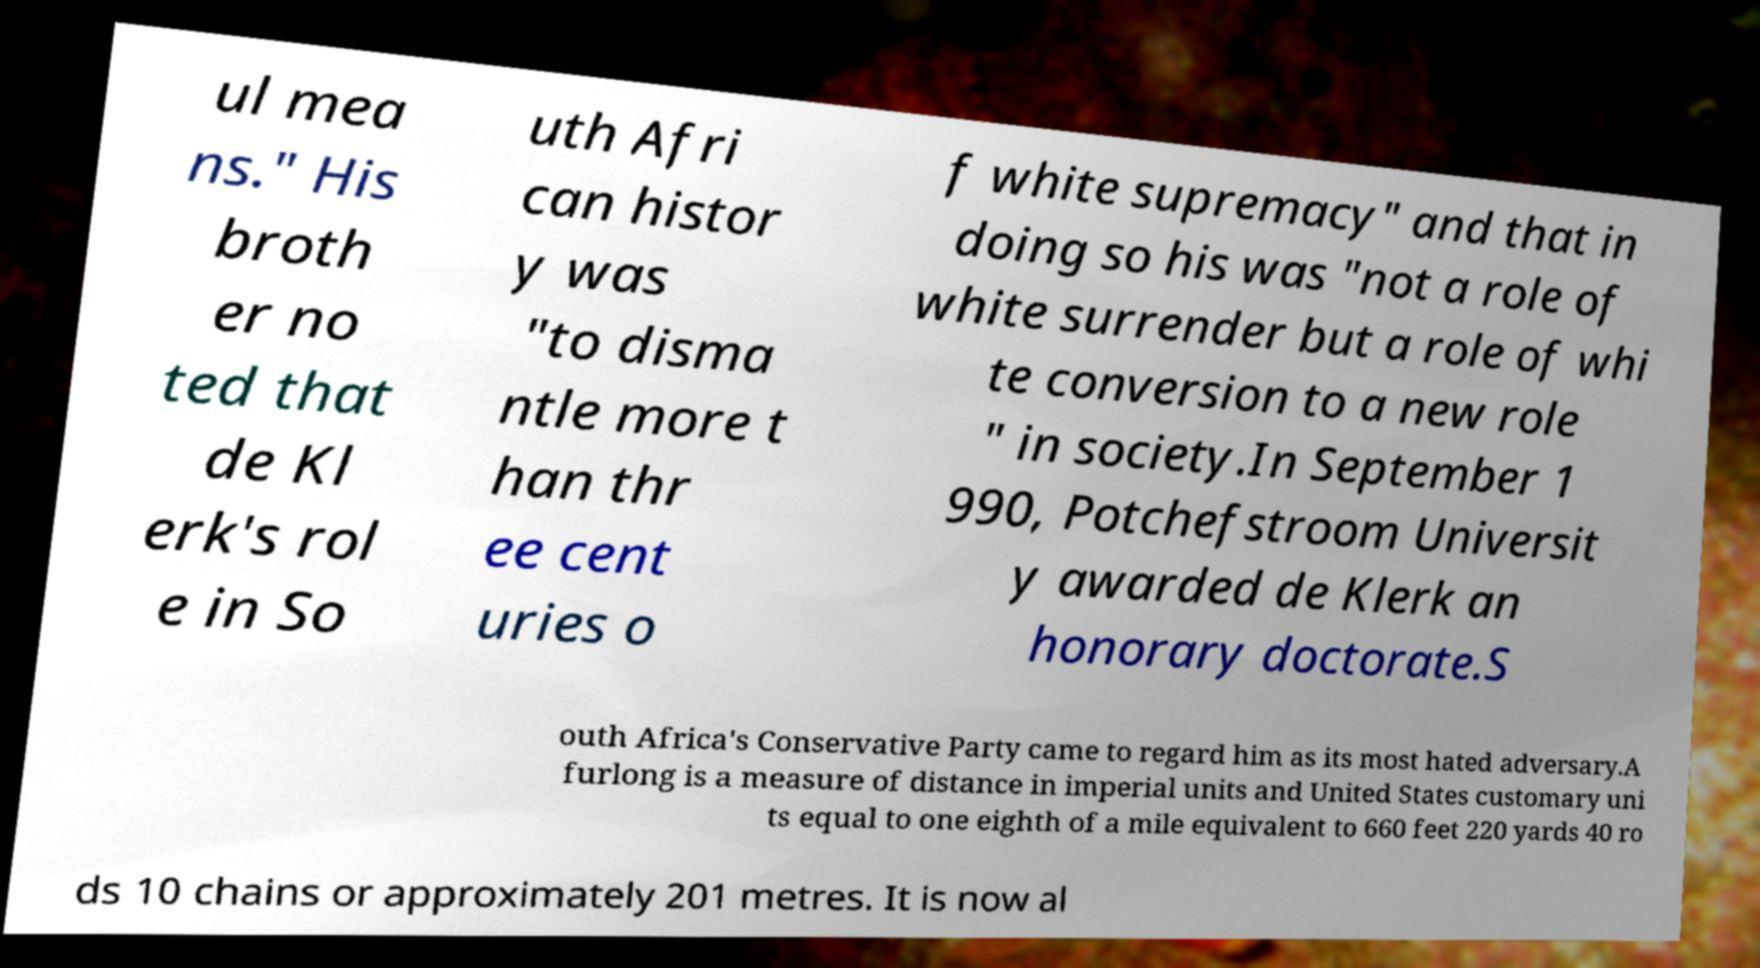Please identify and transcribe the text found in this image. ul mea ns." His broth er no ted that de Kl erk's rol e in So uth Afri can histor y was "to disma ntle more t han thr ee cent uries o f white supremacy" and that in doing so his was "not a role of white surrender but a role of whi te conversion to a new role " in society.In September 1 990, Potchefstroom Universit y awarded de Klerk an honorary doctorate.S outh Africa's Conservative Party came to regard him as its most hated adversary.A furlong is a measure of distance in imperial units and United States customary uni ts equal to one eighth of a mile equivalent to 660 feet 220 yards 40 ro ds 10 chains or approximately 201 metres. It is now al 